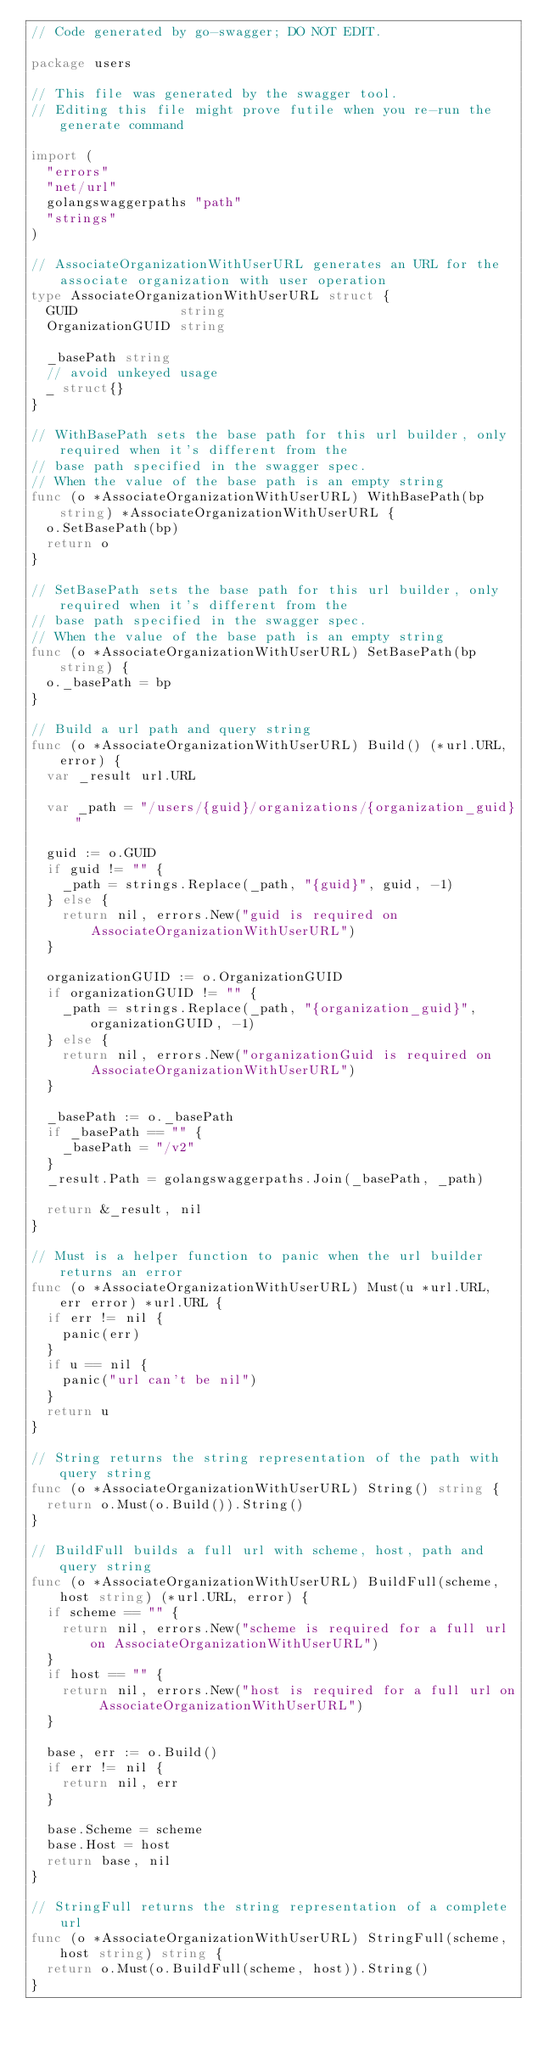<code> <loc_0><loc_0><loc_500><loc_500><_Go_>// Code generated by go-swagger; DO NOT EDIT.

package users

// This file was generated by the swagger tool.
// Editing this file might prove futile when you re-run the generate command

import (
	"errors"
	"net/url"
	golangswaggerpaths "path"
	"strings"
)

// AssociateOrganizationWithUserURL generates an URL for the associate organization with user operation
type AssociateOrganizationWithUserURL struct {
	GUID             string
	OrganizationGUID string

	_basePath string
	// avoid unkeyed usage
	_ struct{}
}

// WithBasePath sets the base path for this url builder, only required when it's different from the
// base path specified in the swagger spec.
// When the value of the base path is an empty string
func (o *AssociateOrganizationWithUserURL) WithBasePath(bp string) *AssociateOrganizationWithUserURL {
	o.SetBasePath(bp)
	return o
}

// SetBasePath sets the base path for this url builder, only required when it's different from the
// base path specified in the swagger spec.
// When the value of the base path is an empty string
func (o *AssociateOrganizationWithUserURL) SetBasePath(bp string) {
	o._basePath = bp
}

// Build a url path and query string
func (o *AssociateOrganizationWithUserURL) Build() (*url.URL, error) {
	var _result url.URL

	var _path = "/users/{guid}/organizations/{organization_guid}"

	guid := o.GUID
	if guid != "" {
		_path = strings.Replace(_path, "{guid}", guid, -1)
	} else {
		return nil, errors.New("guid is required on AssociateOrganizationWithUserURL")
	}

	organizationGUID := o.OrganizationGUID
	if organizationGUID != "" {
		_path = strings.Replace(_path, "{organization_guid}", organizationGUID, -1)
	} else {
		return nil, errors.New("organizationGuid is required on AssociateOrganizationWithUserURL")
	}

	_basePath := o._basePath
	if _basePath == "" {
		_basePath = "/v2"
	}
	_result.Path = golangswaggerpaths.Join(_basePath, _path)

	return &_result, nil
}

// Must is a helper function to panic when the url builder returns an error
func (o *AssociateOrganizationWithUserURL) Must(u *url.URL, err error) *url.URL {
	if err != nil {
		panic(err)
	}
	if u == nil {
		panic("url can't be nil")
	}
	return u
}

// String returns the string representation of the path with query string
func (o *AssociateOrganizationWithUserURL) String() string {
	return o.Must(o.Build()).String()
}

// BuildFull builds a full url with scheme, host, path and query string
func (o *AssociateOrganizationWithUserURL) BuildFull(scheme, host string) (*url.URL, error) {
	if scheme == "" {
		return nil, errors.New("scheme is required for a full url on AssociateOrganizationWithUserURL")
	}
	if host == "" {
		return nil, errors.New("host is required for a full url on AssociateOrganizationWithUserURL")
	}

	base, err := o.Build()
	if err != nil {
		return nil, err
	}

	base.Scheme = scheme
	base.Host = host
	return base, nil
}

// StringFull returns the string representation of a complete url
func (o *AssociateOrganizationWithUserURL) StringFull(scheme, host string) string {
	return o.Must(o.BuildFull(scheme, host)).String()
}
</code> 